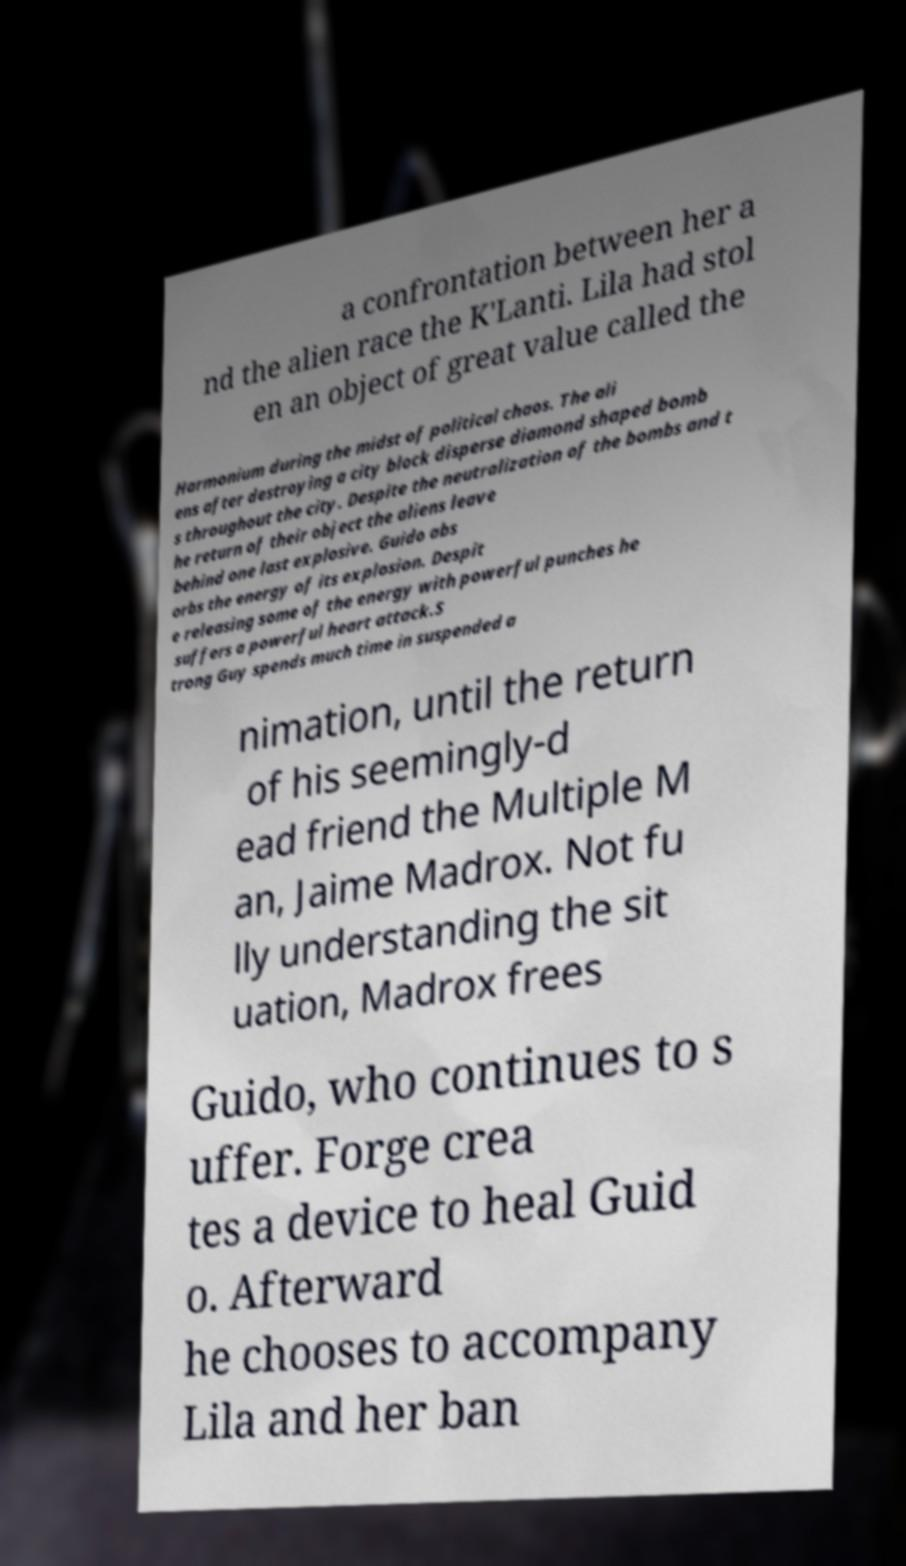Could you extract and type out the text from this image? a confrontation between her a nd the alien race the K'Lanti. Lila had stol en an object of great value called the Harmonium during the midst of political chaos. The ali ens after destroying a city block disperse diamond shaped bomb s throughout the city. Despite the neutralization of the bombs and t he return of their object the aliens leave behind one last explosive. Guido abs orbs the energy of its explosion. Despit e releasing some of the energy with powerful punches he suffers a powerful heart attack.S trong Guy spends much time in suspended a nimation, until the return of his seemingly-d ead friend the Multiple M an, Jaime Madrox. Not fu lly understanding the sit uation, Madrox frees Guido, who continues to s uffer. Forge crea tes a device to heal Guid o. Afterward he chooses to accompany Lila and her ban 